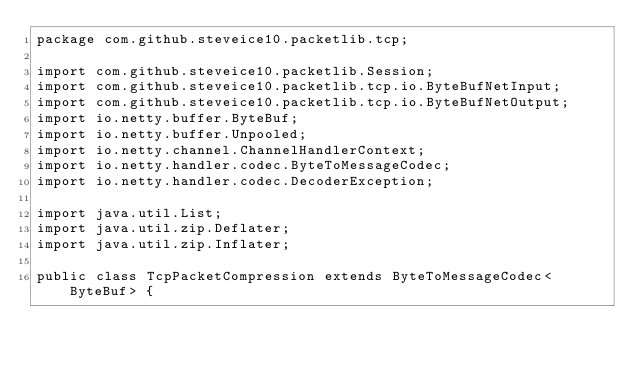<code> <loc_0><loc_0><loc_500><loc_500><_Java_>package com.github.steveice10.packetlib.tcp;

import com.github.steveice10.packetlib.Session;
import com.github.steveice10.packetlib.tcp.io.ByteBufNetInput;
import com.github.steveice10.packetlib.tcp.io.ByteBufNetOutput;
import io.netty.buffer.ByteBuf;
import io.netty.buffer.Unpooled;
import io.netty.channel.ChannelHandlerContext;
import io.netty.handler.codec.ByteToMessageCodec;
import io.netty.handler.codec.DecoderException;

import java.util.List;
import java.util.zip.Deflater;
import java.util.zip.Inflater;

public class TcpPacketCompression extends ByteToMessageCodec<ByteBuf> {</code> 